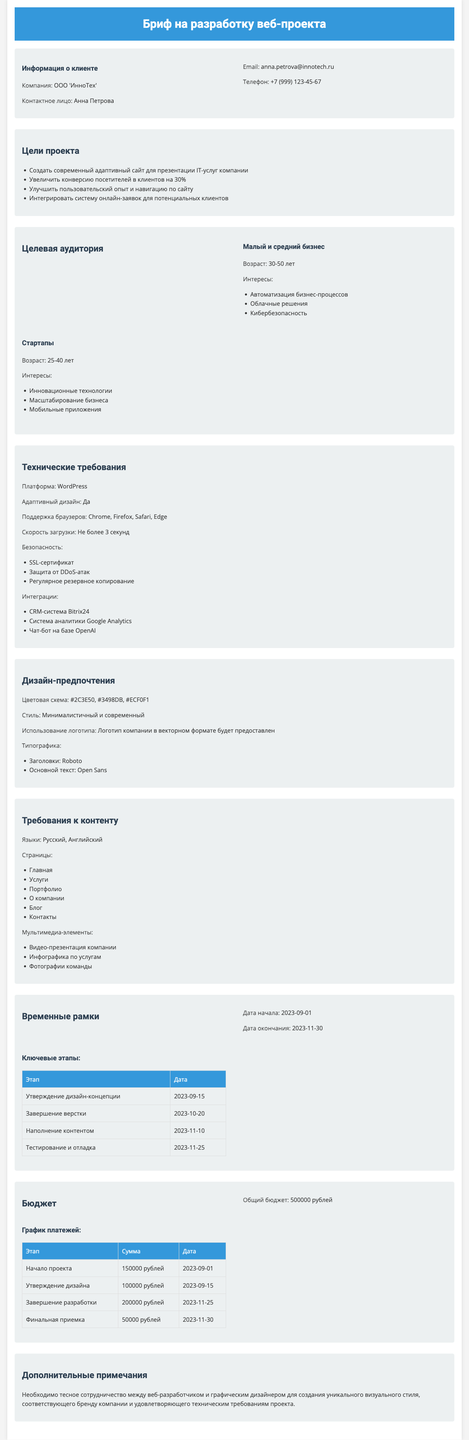What is the name of the client company? The name of the client company is provided in the client information section of the document.
Answer: ООО 'ИнноТех' What is the email of the contact person? The email of the contact person, Anna Petrova, is stated in the client information section.
Answer: anna.petrova@innotech.ru What is the budget for the project? The total budget for the project is specified in the budget section of the document.
Answer: 500000 рублей When is the deadline for testing and debugging? The deadline for testing and debugging is mentioned in the timeline section, which includes milestones.
Answer: 2023-11-25 What is one of the interests of the target audience segment "Стартапы"? The interests of the target audience are listed, and one interest for the segment "Стартапы" can be found there.
Answer: Инновационные технологии How many pages are required for the content? The number of pages required for the content is indicated in the content requirements section of the document.
Answer: 6 What platform is specified for the project? The technical requirements include the platform to be used for the project.
Answer: WordPress Which color is part of the design preferences color scheme? A color listed in the design preferences section can be identified.
Answer: #2C3E50 What is the first milestone date? The first milestone in the timeline section specifies a key date.
Answer: 2023-09-15 